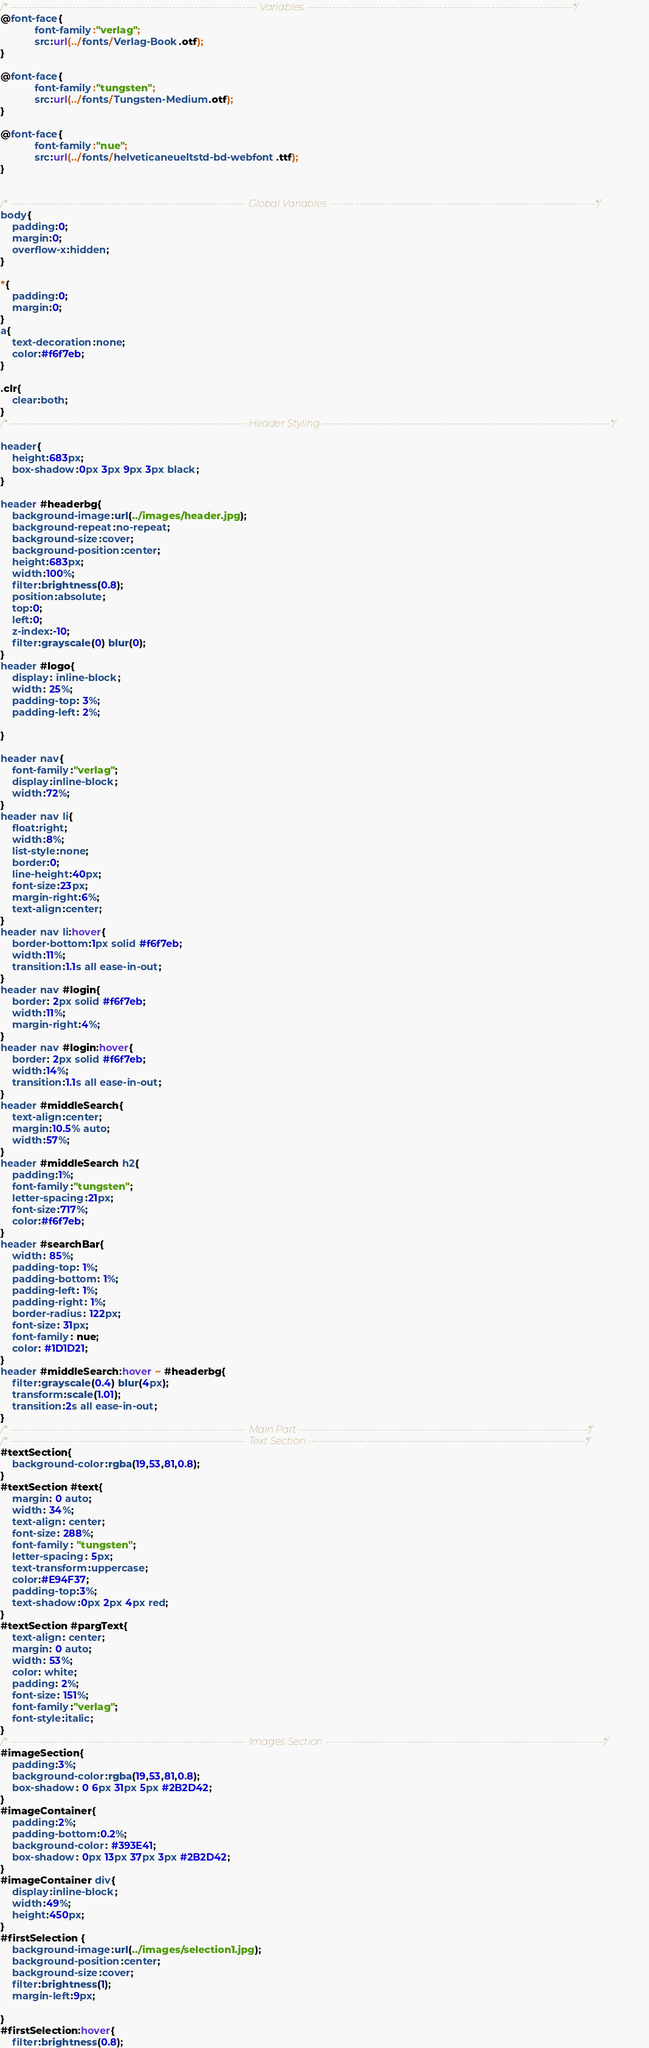<code> <loc_0><loc_0><loc_500><loc_500><_CSS_>/* ------------------------------------------------------------------- Variables ------------------------------------------------------------------------*/
@font-face{
            font-family:"verlag";
            src:url(../fonts/Verlag-Book.otf);
}

@font-face{
            font-family:"tungsten";
            src:url(../fonts/Tungsten-Medium.otf);
}

@font-face{
            font-family:"nue";
            src:url(../fonts/helveticaneueltstd-bd-webfont.ttf);
}


/* ---------------------------------------------------------------- Global Variables ------------------------------------------------------------------------*/
body{
    padding:0;
    margin:0;
    overflow-x:hidden;
}

*{
    padding:0;
    margin:0;
}
a{
    text-decoration:none;
    color:#f6f7eb;
}

.clr{
    clear:both;
}
/* ---------------------------------------------------------------- Header Styling ------------------------------------------------------------------------------*/

header{
    height:683px;
    box-shadow:0px 3px 9px 3px black;
}

header #headerbg{
    background-image:url(../images/header.jpg);
    background-repeat:no-repeat;
    background-size:cover;
    background-position:center;
    height:683px;
    width:100%;
    filter:brightness(0.8);
    position:absolute;
    top:0;
    left:0;
    z-index:-10;
    filter:grayscale(0) blur(0);
}
header #logo{
    display: inline-block;
    width: 25%;
    padding-top: 3%;
    padding-left: 2%;
    
}

header nav{
    font-family:"verlag";
    display:inline-block;
    width:72%;
}
header nav li{
    float:right;
    width:8%;
    list-style:none;
    border:0;
    line-height:40px;
    font-size:23px;
    margin-right:6%;
    text-align:center;
}
header nav li:hover{
    border-bottom:1px solid #f6f7eb;
    width:11%;
    transition:1.1s all ease-in-out;
}
header nav #login{
    border: 2px solid #f6f7eb;
    width:11%;
    margin-right:4%;
}
header nav #login:hover{
    border: 2px solid #f6f7eb;
    width:14%;
    transition:1.1s all ease-in-out;
}
header #middleSearch{
    text-align:center;
    margin:10.5% auto;
    width:57%;
}
header #middleSearch h2{
    padding:1%;
    font-family:"tungsten";
    letter-spacing:21px;
    font-size:717%;
    color:#f6f7eb;
}
header #searchBar{
    width: 85%;
    padding-top: 1%;
    padding-bottom: 1%;
    padding-left: 1%;
    padding-right: 1%;
    border-radius: 122px;
    font-size: 31px;
    font-family: nue;
    color: #1D1D21;
}
header #middleSearch:hover ~ #headerbg{
    filter:grayscale(0.4) blur(4px);
    transform:scale(1.01);
    transition:2s all ease-in-out;
}
/* ---------------------------------------------------------------- Main Part ------------------------------------------------------------------------------*/
/* ---------------------------------------------------------------- Text Section ---------------------------------------------------------------------------*/
#textSection{
    background-color:rgba(19,53,81,0.8);
}
#textSection #text{
    margin: 0 auto;
    width: 34%;
    text-align: center;
    font-size: 288%;
    font-family: "tungsten";
    letter-spacing: 5px;
    text-transform:uppercase;
    color:#E94F37;
    padding-top:3%;
    text-shadow:0px 2px 4px red;
}
#textSection #pargText{
    text-align: center;
    margin: 0 auto;
    width: 53%;
    color: white;
    padding: 2%;
    font-size: 151%;
    font-family:"verlag";
    font-style:italic;
}
/* ---------------------------------------------------------------- Images Section ---------------------------------------------------------------------------*/
#imageSection{
    padding:3%;
    background-color:rgba(19,53,81,0.8);
    box-shadow: 0 6px 31px 5px #2B2D42;
}
#imageContainer{
    padding:2%;
    padding-bottom:0.2%;
    background-color: #393E41;
    box-shadow: 0px 13px 37px 3px #2B2D42;
}
#imageContainer div{
    display:inline-block;
    width:49%;
    height:450px;
}
#firstSelection {
    background-image:url(../images/selection1.jpg);
    background-position:center;
    background-size:cover;
    filter:brightness(1);
    margin-left:9px;
    
}
#firstSelection:hover{
    filter:brightness(0.8);</code> 